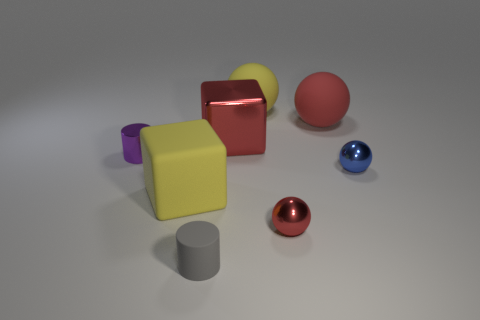Subtract all red rubber spheres. How many spheres are left? 3 Add 1 large yellow matte things. How many objects exist? 9 Subtract all red cubes. How many cubes are left? 1 Subtract 1 blocks. How many blocks are left? 1 Add 5 yellow objects. How many yellow objects are left? 7 Add 1 small purple matte things. How many small purple matte things exist? 1 Subtract 0 yellow cylinders. How many objects are left? 8 Subtract all cylinders. How many objects are left? 6 Subtract all brown cylinders. Subtract all purple spheres. How many cylinders are left? 2 Subtract all purple balls. How many yellow cubes are left? 1 